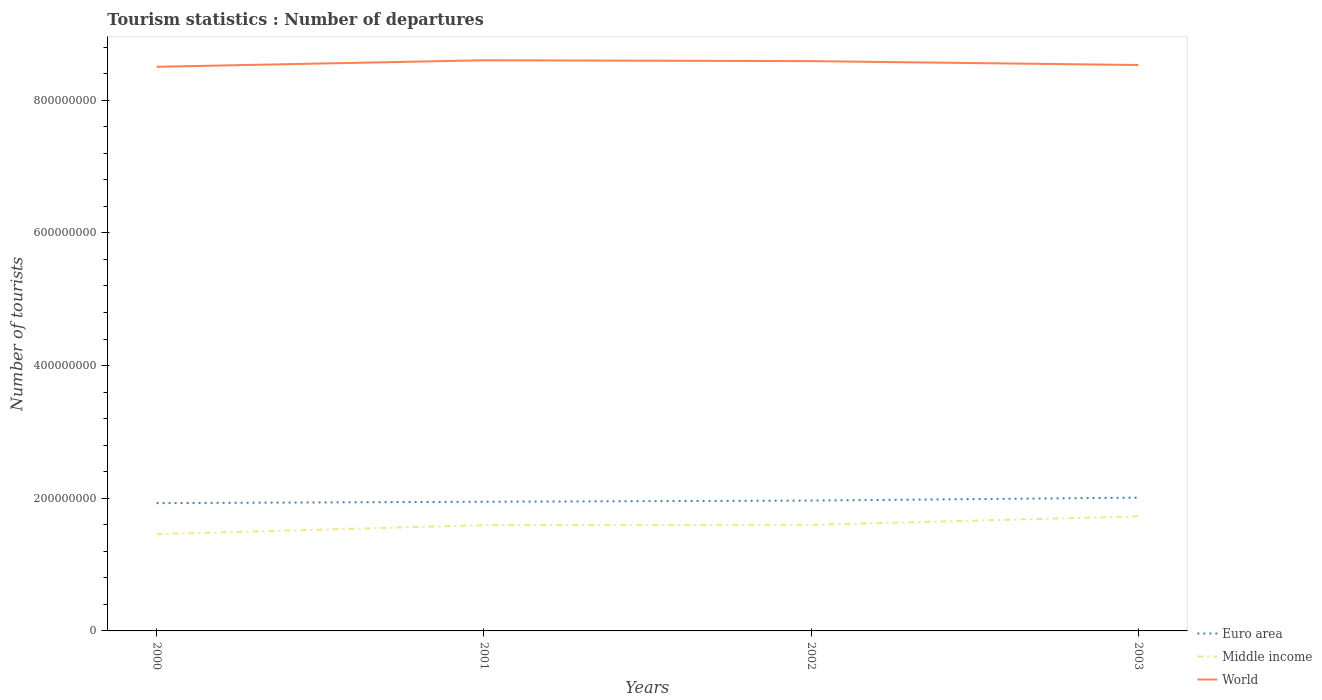How many different coloured lines are there?
Provide a short and direct response. 3. Does the line corresponding to Middle income intersect with the line corresponding to World?
Ensure brevity in your answer.  No. Across all years, what is the maximum number of tourist departures in Euro area?
Make the answer very short. 1.93e+08. In which year was the number of tourist departures in World maximum?
Ensure brevity in your answer.  2000. What is the total number of tourist departures in World in the graph?
Offer a very short reply. 1.29e+06. What is the difference between the highest and the second highest number of tourist departures in World?
Offer a very short reply. 9.83e+06. Is the number of tourist departures in Euro area strictly greater than the number of tourist departures in Middle income over the years?
Ensure brevity in your answer.  No. What is the difference between two consecutive major ticks on the Y-axis?
Offer a terse response. 2.00e+08. Does the graph contain any zero values?
Provide a succinct answer. No. Does the graph contain grids?
Offer a terse response. No. What is the title of the graph?
Make the answer very short. Tourism statistics : Number of departures. Does "South Asia" appear as one of the legend labels in the graph?
Offer a very short reply. No. What is the label or title of the X-axis?
Make the answer very short. Years. What is the label or title of the Y-axis?
Give a very brief answer. Number of tourists. What is the Number of tourists of Euro area in 2000?
Your answer should be very brief. 1.93e+08. What is the Number of tourists of Middle income in 2000?
Provide a succinct answer. 1.46e+08. What is the Number of tourists of World in 2000?
Keep it short and to the point. 8.50e+08. What is the Number of tourists of Euro area in 2001?
Make the answer very short. 1.95e+08. What is the Number of tourists of Middle income in 2001?
Ensure brevity in your answer.  1.59e+08. What is the Number of tourists of World in 2001?
Make the answer very short. 8.60e+08. What is the Number of tourists in Euro area in 2002?
Make the answer very short. 1.96e+08. What is the Number of tourists of Middle income in 2002?
Ensure brevity in your answer.  1.60e+08. What is the Number of tourists in World in 2002?
Offer a very short reply. 8.59e+08. What is the Number of tourists in Euro area in 2003?
Your answer should be very brief. 2.01e+08. What is the Number of tourists in Middle income in 2003?
Offer a terse response. 1.73e+08. What is the Number of tourists of World in 2003?
Make the answer very short. 8.53e+08. Across all years, what is the maximum Number of tourists of Euro area?
Your answer should be compact. 2.01e+08. Across all years, what is the maximum Number of tourists of Middle income?
Offer a terse response. 1.73e+08. Across all years, what is the maximum Number of tourists in World?
Provide a short and direct response. 8.60e+08. Across all years, what is the minimum Number of tourists of Euro area?
Ensure brevity in your answer.  1.93e+08. Across all years, what is the minimum Number of tourists of Middle income?
Provide a short and direct response. 1.46e+08. Across all years, what is the minimum Number of tourists of World?
Provide a short and direct response. 8.50e+08. What is the total Number of tourists of Euro area in the graph?
Offer a terse response. 7.85e+08. What is the total Number of tourists in Middle income in the graph?
Keep it short and to the point. 6.38e+08. What is the total Number of tourists in World in the graph?
Provide a succinct answer. 3.42e+09. What is the difference between the Number of tourists of Euro area in 2000 and that in 2001?
Make the answer very short. -2.08e+06. What is the difference between the Number of tourists of Middle income in 2000 and that in 2001?
Make the answer very short. -1.36e+07. What is the difference between the Number of tourists in World in 2000 and that in 2001?
Provide a succinct answer. -9.83e+06. What is the difference between the Number of tourists in Euro area in 2000 and that in 2002?
Give a very brief answer. -3.85e+06. What is the difference between the Number of tourists in Middle income in 2000 and that in 2002?
Your answer should be compact. -1.41e+07. What is the difference between the Number of tourists in World in 2000 and that in 2002?
Make the answer very short. -8.54e+06. What is the difference between the Number of tourists of Euro area in 2000 and that in 2003?
Provide a short and direct response. -8.28e+06. What is the difference between the Number of tourists of Middle income in 2000 and that in 2003?
Make the answer very short. -2.68e+07. What is the difference between the Number of tourists in World in 2000 and that in 2003?
Offer a very short reply. -2.67e+06. What is the difference between the Number of tourists in Euro area in 2001 and that in 2002?
Your answer should be compact. -1.77e+06. What is the difference between the Number of tourists in Middle income in 2001 and that in 2002?
Offer a terse response. -4.80e+05. What is the difference between the Number of tourists of World in 2001 and that in 2002?
Make the answer very short. 1.29e+06. What is the difference between the Number of tourists of Euro area in 2001 and that in 2003?
Your answer should be very brief. -6.20e+06. What is the difference between the Number of tourists of Middle income in 2001 and that in 2003?
Your answer should be compact. -1.32e+07. What is the difference between the Number of tourists in World in 2001 and that in 2003?
Your answer should be very brief. 7.17e+06. What is the difference between the Number of tourists of Euro area in 2002 and that in 2003?
Your answer should be compact. -4.43e+06. What is the difference between the Number of tourists in Middle income in 2002 and that in 2003?
Offer a very short reply. -1.27e+07. What is the difference between the Number of tourists of World in 2002 and that in 2003?
Your answer should be compact. 5.87e+06. What is the difference between the Number of tourists in Euro area in 2000 and the Number of tourists in Middle income in 2001?
Your response must be concise. 3.32e+07. What is the difference between the Number of tourists in Euro area in 2000 and the Number of tourists in World in 2001?
Your response must be concise. -6.68e+08. What is the difference between the Number of tourists in Middle income in 2000 and the Number of tourists in World in 2001?
Provide a succinct answer. -7.14e+08. What is the difference between the Number of tourists in Euro area in 2000 and the Number of tourists in Middle income in 2002?
Ensure brevity in your answer.  3.27e+07. What is the difference between the Number of tourists of Euro area in 2000 and the Number of tourists of World in 2002?
Your answer should be compact. -6.66e+08. What is the difference between the Number of tourists of Middle income in 2000 and the Number of tourists of World in 2002?
Offer a terse response. -7.13e+08. What is the difference between the Number of tourists of Euro area in 2000 and the Number of tourists of Middle income in 2003?
Provide a succinct answer. 2.00e+07. What is the difference between the Number of tourists in Euro area in 2000 and the Number of tourists in World in 2003?
Your answer should be compact. -6.60e+08. What is the difference between the Number of tourists of Middle income in 2000 and the Number of tourists of World in 2003?
Keep it short and to the point. -7.07e+08. What is the difference between the Number of tourists of Euro area in 2001 and the Number of tourists of Middle income in 2002?
Give a very brief answer. 3.48e+07. What is the difference between the Number of tourists in Euro area in 2001 and the Number of tourists in World in 2002?
Your answer should be compact. -6.64e+08. What is the difference between the Number of tourists of Middle income in 2001 and the Number of tourists of World in 2002?
Your answer should be very brief. -6.99e+08. What is the difference between the Number of tourists of Euro area in 2001 and the Number of tourists of Middle income in 2003?
Ensure brevity in your answer.  2.21e+07. What is the difference between the Number of tourists of Euro area in 2001 and the Number of tourists of World in 2003?
Offer a terse response. -6.58e+08. What is the difference between the Number of tourists of Middle income in 2001 and the Number of tourists of World in 2003?
Your response must be concise. -6.94e+08. What is the difference between the Number of tourists in Euro area in 2002 and the Number of tourists in Middle income in 2003?
Offer a terse response. 2.38e+07. What is the difference between the Number of tourists of Euro area in 2002 and the Number of tourists of World in 2003?
Your answer should be compact. -6.57e+08. What is the difference between the Number of tourists in Middle income in 2002 and the Number of tourists in World in 2003?
Keep it short and to the point. -6.93e+08. What is the average Number of tourists of Euro area per year?
Your response must be concise. 1.96e+08. What is the average Number of tourists in Middle income per year?
Your response must be concise. 1.59e+08. What is the average Number of tourists in World per year?
Keep it short and to the point. 8.56e+08. In the year 2000, what is the difference between the Number of tourists in Euro area and Number of tourists in Middle income?
Keep it short and to the point. 4.68e+07. In the year 2000, what is the difference between the Number of tourists in Euro area and Number of tourists in World?
Give a very brief answer. -6.58e+08. In the year 2000, what is the difference between the Number of tourists of Middle income and Number of tourists of World?
Give a very brief answer. -7.04e+08. In the year 2001, what is the difference between the Number of tourists in Euro area and Number of tourists in Middle income?
Offer a very short reply. 3.53e+07. In the year 2001, what is the difference between the Number of tourists of Euro area and Number of tourists of World?
Keep it short and to the point. -6.65e+08. In the year 2001, what is the difference between the Number of tourists of Middle income and Number of tourists of World?
Your response must be concise. -7.01e+08. In the year 2002, what is the difference between the Number of tourists of Euro area and Number of tourists of Middle income?
Give a very brief answer. 3.66e+07. In the year 2002, what is the difference between the Number of tourists of Euro area and Number of tourists of World?
Ensure brevity in your answer.  -6.62e+08. In the year 2002, what is the difference between the Number of tourists in Middle income and Number of tourists in World?
Keep it short and to the point. -6.99e+08. In the year 2003, what is the difference between the Number of tourists in Euro area and Number of tourists in Middle income?
Ensure brevity in your answer.  2.83e+07. In the year 2003, what is the difference between the Number of tourists of Euro area and Number of tourists of World?
Offer a very short reply. -6.52e+08. In the year 2003, what is the difference between the Number of tourists of Middle income and Number of tourists of World?
Ensure brevity in your answer.  -6.80e+08. What is the ratio of the Number of tourists in Euro area in 2000 to that in 2001?
Provide a short and direct response. 0.99. What is the ratio of the Number of tourists of Middle income in 2000 to that in 2001?
Provide a short and direct response. 0.91. What is the ratio of the Number of tourists of Euro area in 2000 to that in 2002?
Your answer should be compact. 0.98. What is the ratio of the Number of tourists in Middle income in 2000 to that in 2002?
Provide a succinct answer. 0.91. What is the ratio of the Number of tourists of Euro area in 2000 to that in 2003?
Your answer should be very brief. 0.96. What is the ratio of the Number of tourists of Middle income in 2000 to that in 2003?
Keep it short and to the point. 0.84. What is the ratio of the Number of tourists in Euro area in 2001 to that in 2003?
Offer a terse response. 0.97. What is the ratio of the Number of tourists in Middle income in 2001 to that in 2003?
Make the answer very short. 0.92. What is the ratio of the Number of tourists in World in 2001 to that in 2003?
Keep it short and to the point. 1.01. What is the ratio of the Number of tourists in Euro area in 2002 to that in 2003?
Offer a terse response. 0.98. What is the ratio of the Number of tourists of Middle income in 2002 to that in 2003?
Provide a short and direct response. 0.93. What is the ratio of the Number of tourists of World in 2002 to that in 2003?
Make the answer very short. 1.01. What is the difference between the highest and the second highest Number of tourists of Euro area?
Offer a very short reply. 4.43e+06. What is the difference between the highest and the second highest Number of tourists in Middle income?
Provide a succinct answer. 1.27e+07. What is the difference between the highest and the second highest Number of tourists of World?
Offer a very short reply. 1.29e+06. What is the difference between the highest and the lowest Number of tourists of Euro area?
Offer a very short reply. 8.28e+06. What is the difference between the highest and the lowest Number of tourists of Middle income?
Keep it short and to the point. 2.68e+07. What is the difference between the highest and the lowest Number of tourists of World?
Ensure brevity in your answer.  9.83e+06. 